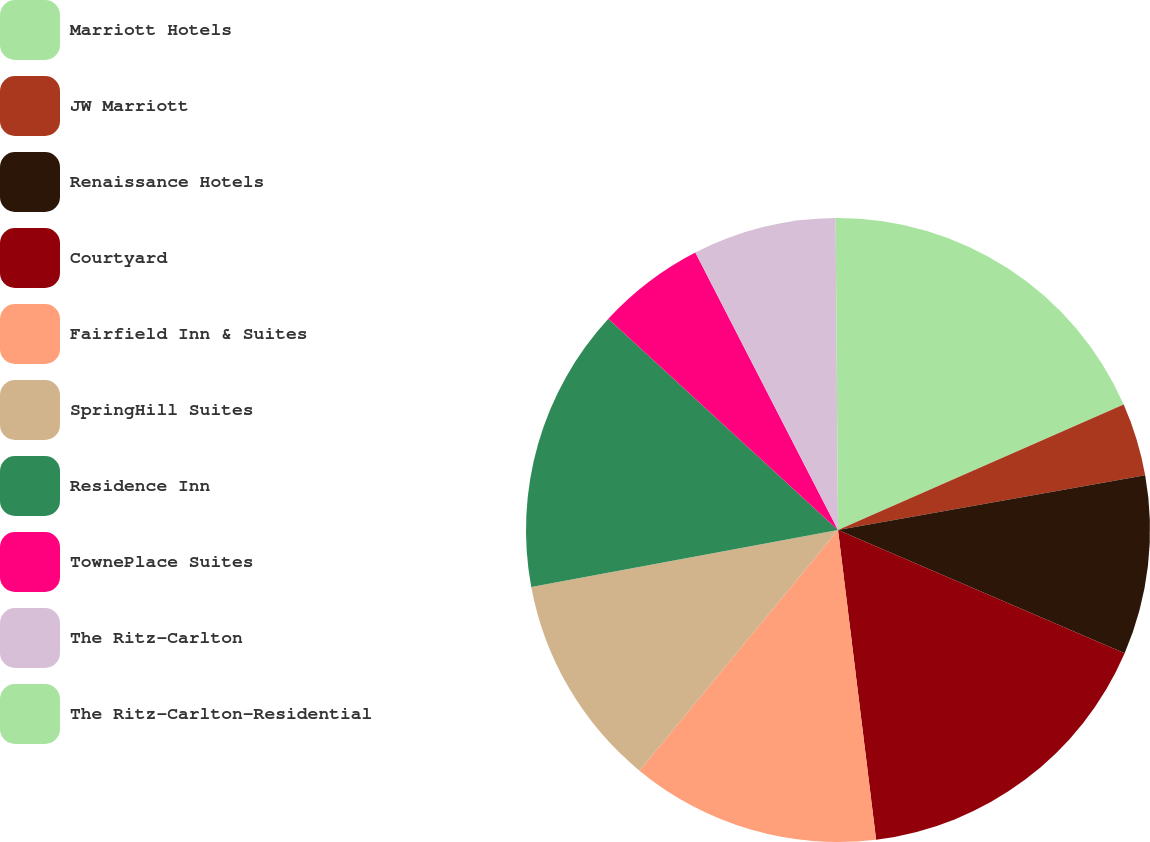Convert chart. <chart><loc_0><loc_0><loc_500><loc_500><pie_chart><fcel>Marriott Hotels<fcel>JW Marriott<fcel>Renaissance Hotels<fcel>Courtyard<fcel>Fairfield Inn & Suites<fcel>SpringHill Suites<fcel>Residence Inn<fcel>TownePlace Suites<fcel>The Ritz-Carlton<fcel>The Ritz-Carlton-Residential<nl><fcel>18.42%<fcel>3.78%<fcel>9.27%<fcel>16.59%<fcel>12.93%<fcel>11.1%<fcel>14.76%<fcel>5.61%<fcel>7.44%<fcel>0.12%<nl></chart> 